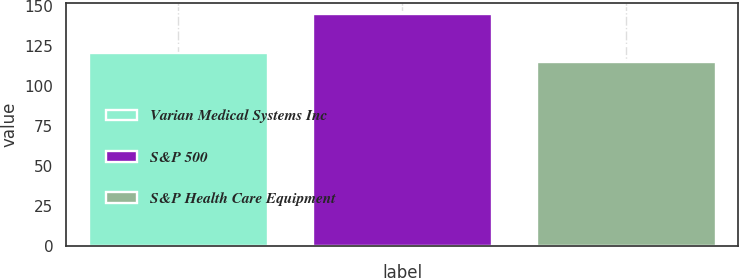<chart> <loc_0><loc_0><loc_500><loc_500><bar_chart><fcel>Varian Medical Systems Inc<fcel>S&P 500<fcel>S&P Health Care Equipment<nl><fcel>120.93<fcel>144.81<fcel>114.76<nl></chart> 